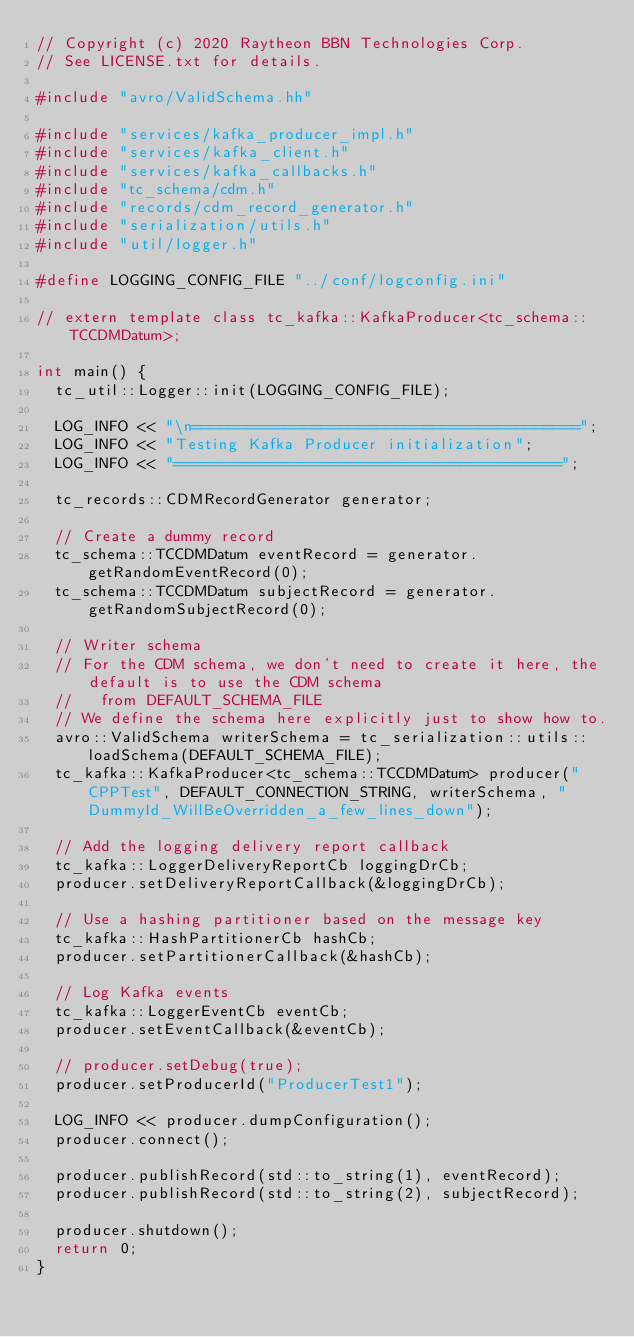Convert code to text. <code><loc_0><loc_0><loc_500><loc_500><_C++_>// Copyright (c) 2020 Raytheon BBN Technologies Corp.
// See LICENSE.txt for details.

#include "avro/ValidSchema.hh"

#include "services/kafka_producer_impl.h"
#include "services/kafka_client.h"
#include "services/kafka_callbacks.h"
#include "tc_schema/cdm.h"
#include "records/cdm_record_generator.h"
#include "serialization/utils.h"
#include "util/logger.h"

#define LOGGING_CONFIG_FILE "../conf/logconfig.ini"

// extern template class tc_kafka::KafkaProducer<tc_schema::TCCDMDatum>;

int main() {
  tc_util::Logger::init(LOGGING_CONFIG_FILE);

  LOG_INFO << "\n==========================================";
  LOG_INFO << "Testing Kafka Producer initialization";
  LOG_INFO << "==========================================";

  tc_records::CDMRecordGenerator generator;

  // Create a dummy record
  tc_schema::TCCDMDatum eventRecord = generator.getRandomEventRecord(0);
  tc_schema::TCCDMDatum subjectRecord = generator.getRandomSubjectRecord(0);

  // Writer schema
  // For the CDM schema, we don't need to create it here, the default is to use the CDM schema
  //   from DEFAULT_SCHEMA_FILE
  // We define the schema here explicitly just to show how to.
  avro::ValidSchema writerSchema = tc_serialization::utils::loadSchema(DEFAULT_SCHEMA_FILE);
  tc_kafka::KafkaProducer<tc_schema::TCCDMDatum> producer("CPPTest", DEFAULT_CONNECTION_STRING, writerSchema, "DummyId_WillBeOverridden_a_few_lines_down");

  // Add the logging delivery report callback
  tc_kafka::LoggerDeliveryReportCb loggingDrCb;
  producer.setDeliveryReportCallback(&loggingDrCb);

  // Use a hashing partitioner based on the message key
  tc_kafka::HashPartitionerCb hashCb;
  producer.setPartitionerCallback(&hashCb);

  // Log Kafka events 
  tc_kafka::LoggerEventCb eventCb;
  producer.setEventCallback(&eventCb);

  // producer.setDebug(true);
  producer.setProducerId("ProducerTest1");

  LOG_INFO << producer.dumpConfiguration();
  producer.connect();

  producer.publishRecord(std::to_string(1), eventRecord);
  producer.publishRecord(std::to_string(2), subjectRecord);
  
  producer.shutdown();
  return 0;
}
</code> 